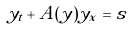<formula> <loc_0><loc_0><loc_500><loc_500>y _ { t } + A ( y ) y _ { x } = s</formula> 